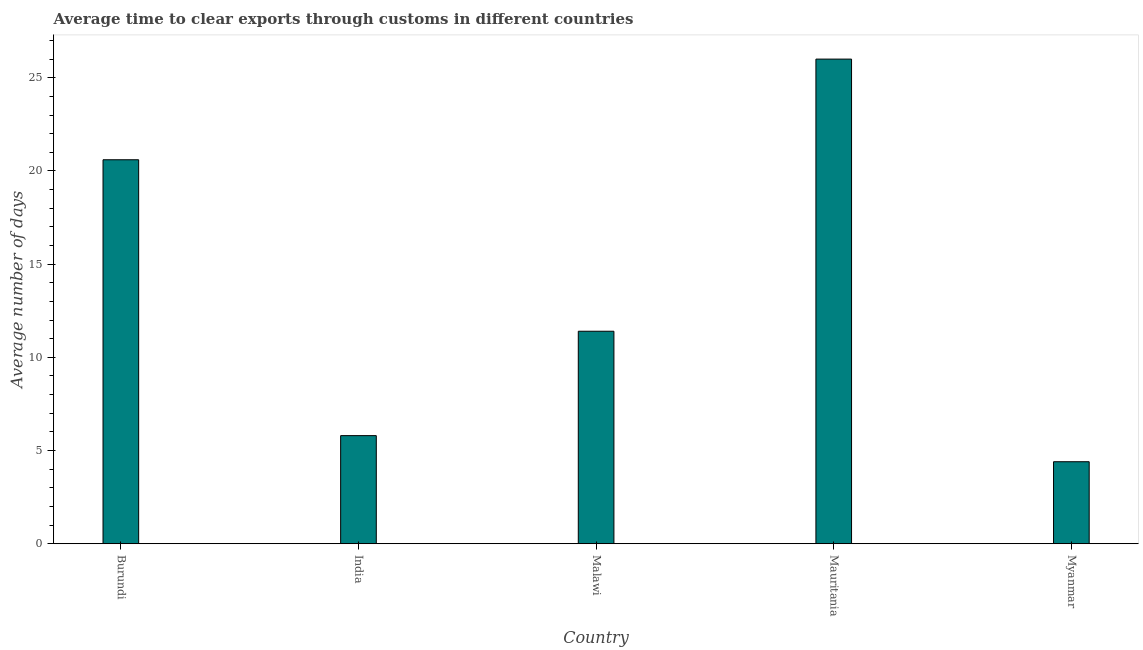What is the title of the graph?
Your answer should be compact. Average time to clear exports through customs in different countries. What is the label or title of the Y-axis?
Keep it short and to the point. Average number of days. What is the time to clear exports through customs in Burundi?
Provide a succinct answer. 20.6. Across all countries, what is the maximum time to clear exports through customs?
Make the answer very short. 26. Across all countries, what is the minimum time to clear exports through customs?
Provide a short and direct response. 4.4. In which country was the time to clear exports through customs maximum?
Offer a terse response. Mauritania. In which country was the time to clear exports through customs minimum?
Make the answer very short. Myanmar. What is the sum of the time to clear exports through customs?
Ensure brevity in your answer.  68.2. What is the average time to clear exports through customs per country?
Provide a succinct answer. 13.64. What is the median time to clear exports through customs?
Provide a short and direct response. 11.4. What is the ratio of the time to clear exports through customs in India to that in Myanmar?
Offer a terse response. 1.32. What is the difference between the highest and the lowest time to clear exports through customs?
Provide a succinct answer. 21.6. How many countries are there in the graph?
Provide a succinct answer. 5. Are the values on the major ticks of Y-axis written in scientific E-notation?
Give a very brief answer. No. What is the Average number of days in Burundi?
Your response must be concise. 20.6. What is the difference between the Average number of days in Burundi and Malawi?
Your answer should be compact. 9.2. What is the difference between the Average number of days in Burundi and Mauritania?
Your answer should be very brief. -5.4. What is the difference between the Average number of days in India and Mauritania?
Offer a terse response. -20.2. What is the difference between the Average number of days in Malawi and Mauritania?
Provide a short and direct response. -14.6. What is the difference between the Average number of days in Malawi and Myanmar?
Provide a succinct answer. 7. What is the difference between the Average number of days in Mauritania and Myanmar?
Offer a very short reply. 21.6. What is the ratio of the Average number of days in Burundi to that in India?
Provide a short and direct response. 3.55. What is the ratio of the Average number of days in Burundi to that in Malawi?
Give a very brief answer. 1.81. What is the ratio of the Average number of days in Burundi to that in Mauritania?
Provide a succinct answer. 0.79. What is the ratio of the Average number of days in Burundi to that in Myanmar?
Offer a terse response. 4.68. What is the ratio of the Average number of days in India to that in Malawi?
Make the answer very short. 0.51. What is the ratio of the Average number of days in India to that in Mauritania?
Offer a terse response. 0.22. What is the ratio of the Average number of days in India to that in Myanmar?
Give a very brief answer. 1.32. What is the ratio of the Average number of days in Malawi to that in Mauritania?
Your answer should be compact. 0.44. What is the ratio of the Average number of days in Malawi to that in Myanmar?
Offer a very short reply. 2.59. What is the ratio of the Average number of days in Mauritania to that in Myanmar?
Your answer should be compact. 5.91. 